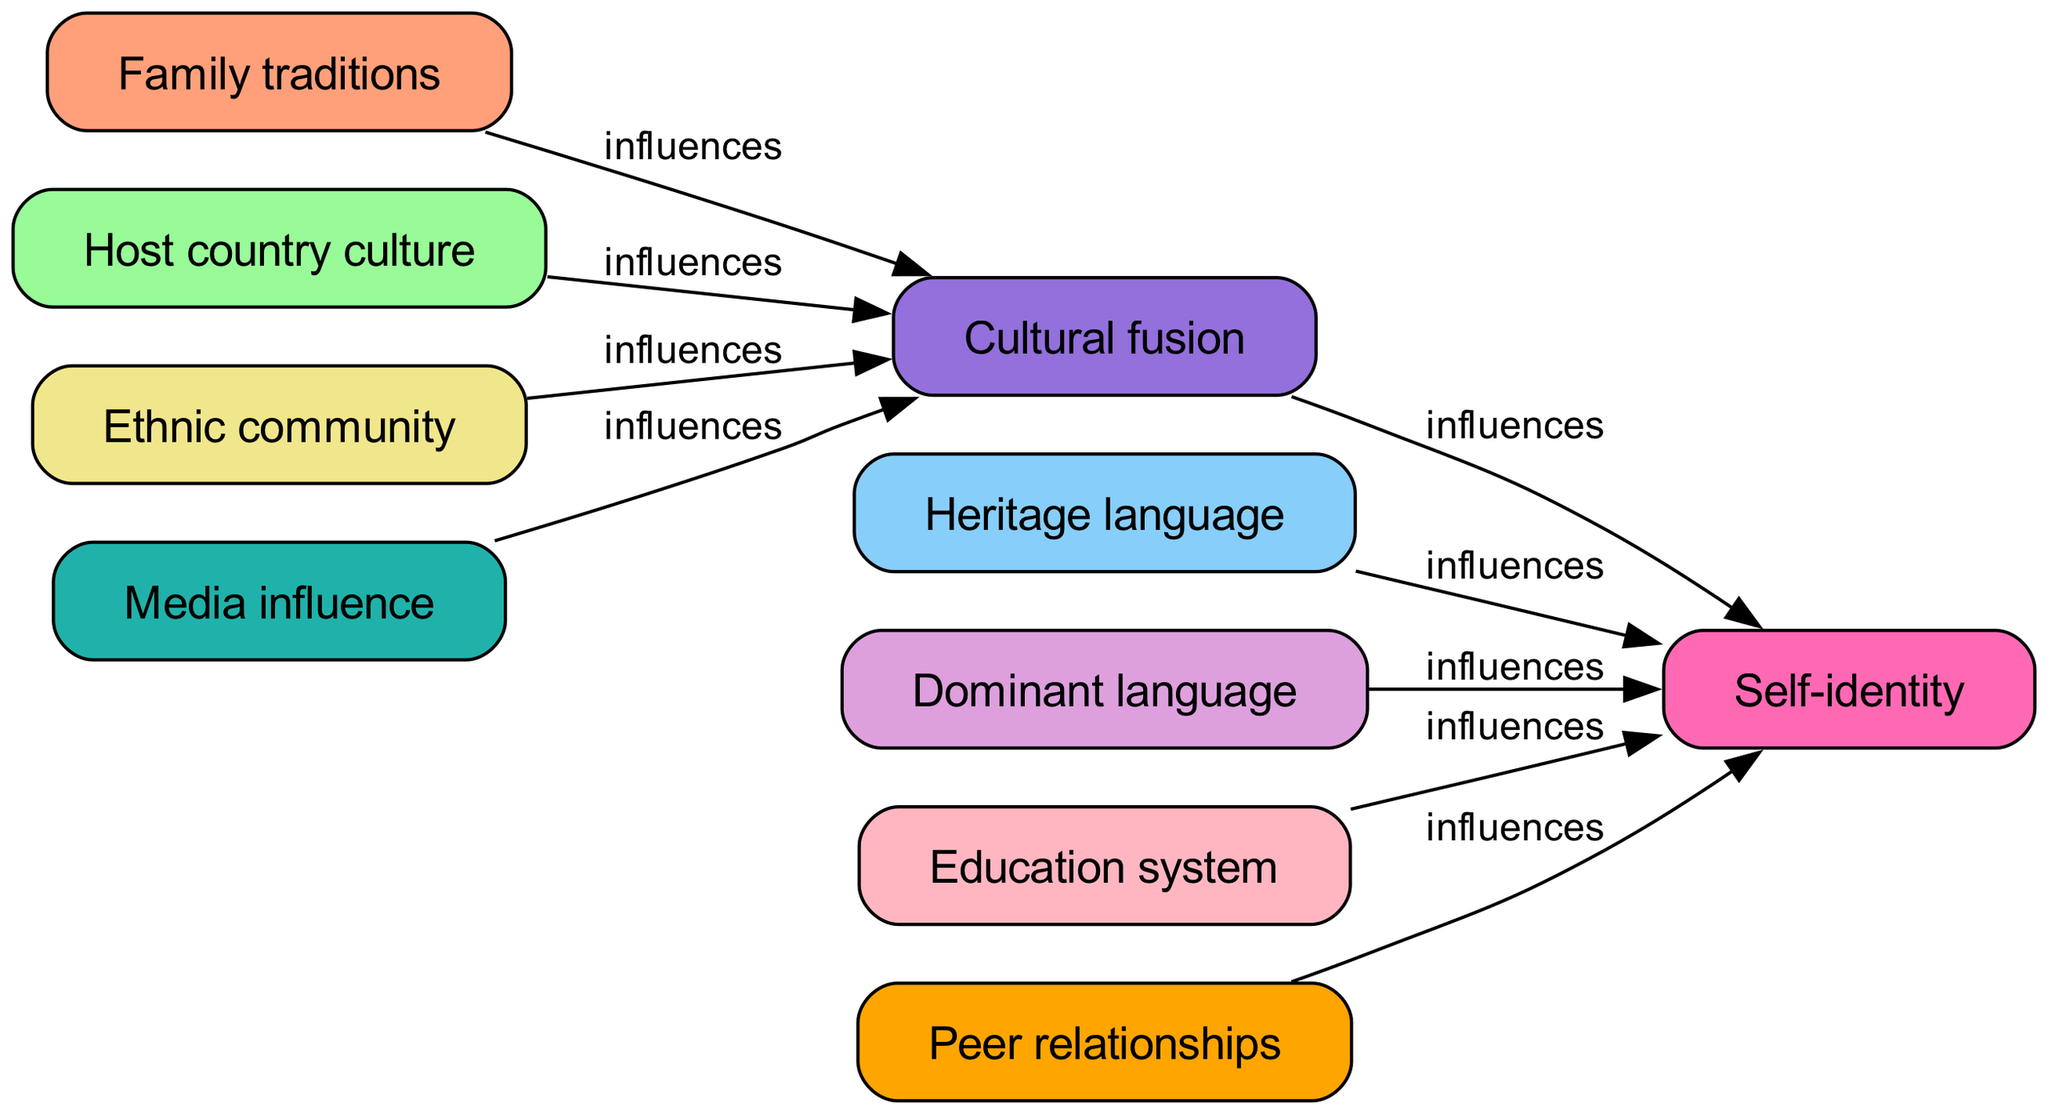What is the total number of nodes in the diagram? The diagram lists ten unique aspects related to the cultural identity formation process, which includes "Family traditions," "Host country culture," "Heritage language," "Dominant language," "Ethnic community," "Education system," "Media influence," "Peer relationships," "Cultural fusion," and "Self-identity." Therefore, the total number of nodes is 10.
Answer: 10 Which node is influenced by both "Host country culture" and "Media influence"? To determine this, we look for the node that has edges coming from both "Host country culture" and "Media influence." The node "Cultural fusion" has direct edges from both these sources, indicating it is influenced by them.
Answer: Cultural fusion How many edges originate from "Ethnic community"? Analyzing the edges coming from "Ethnic community," there is one directed edge leading to "Cultural fusion." Therefore, the number of edges originating from "Ethnic community" is 1.
Answer: 1 What influences "Self-identity"? The node "Self-identity" has influences from several nodes: "Heritage language," "Dominant language," "Education system," "Peer relationships," and "Cultural fusion." All these nodes contribute to the shaping of self-identity.
Answer: Heritage language, Dominant language, Education system, Peer relationships, Cultural fusion What is the direct relationship between "Family traditions" and "Self-identity"? "Family traditions" does not have a direct edge leading to "Self-identity." Instead, it influences "Cultural fusion," which then connects to "Self-identity." This indicates an indirect relationship rather than a direct one.
Answer: No direct relationship Which nodes contribute to "Cultural fusion" and also influence "Self-identity"? The nodes that contribute to "Cultural fusion" are "Family traditions," "Host country culture," "Ethnic community," and "Media influence." Out of these, only "Cultural fusion" itself also influences "Self-identity." Therefore, the only node that influences both is "Cultural fusion."
Answer: Cultural fusion What role does the "Education system" play in this diagram? The "Education system" has a directed edge flowing into "Self-identity," indicating that it plays a role in influencing an individual's self-identity in the context of cultural identity formation. Therefore, it contributes do defining how second-generation immigrants perceive themselves.
Answer: Influences self-identity Which two nodes have a direct influence on "Cultural fusion"? The nodes "Family traditions" and "Host country culture" both have direct edges leading to "Cultural fusion," indicating their influence in this process of cultural merging. Therefore, these two nodes actively shape the cultural fusion aspect.
Answer: Family traditions, Host country culture 